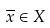<formula> <loc_0><loc_0><loc_500><loc_500>\overline { x } \in X</formula> 